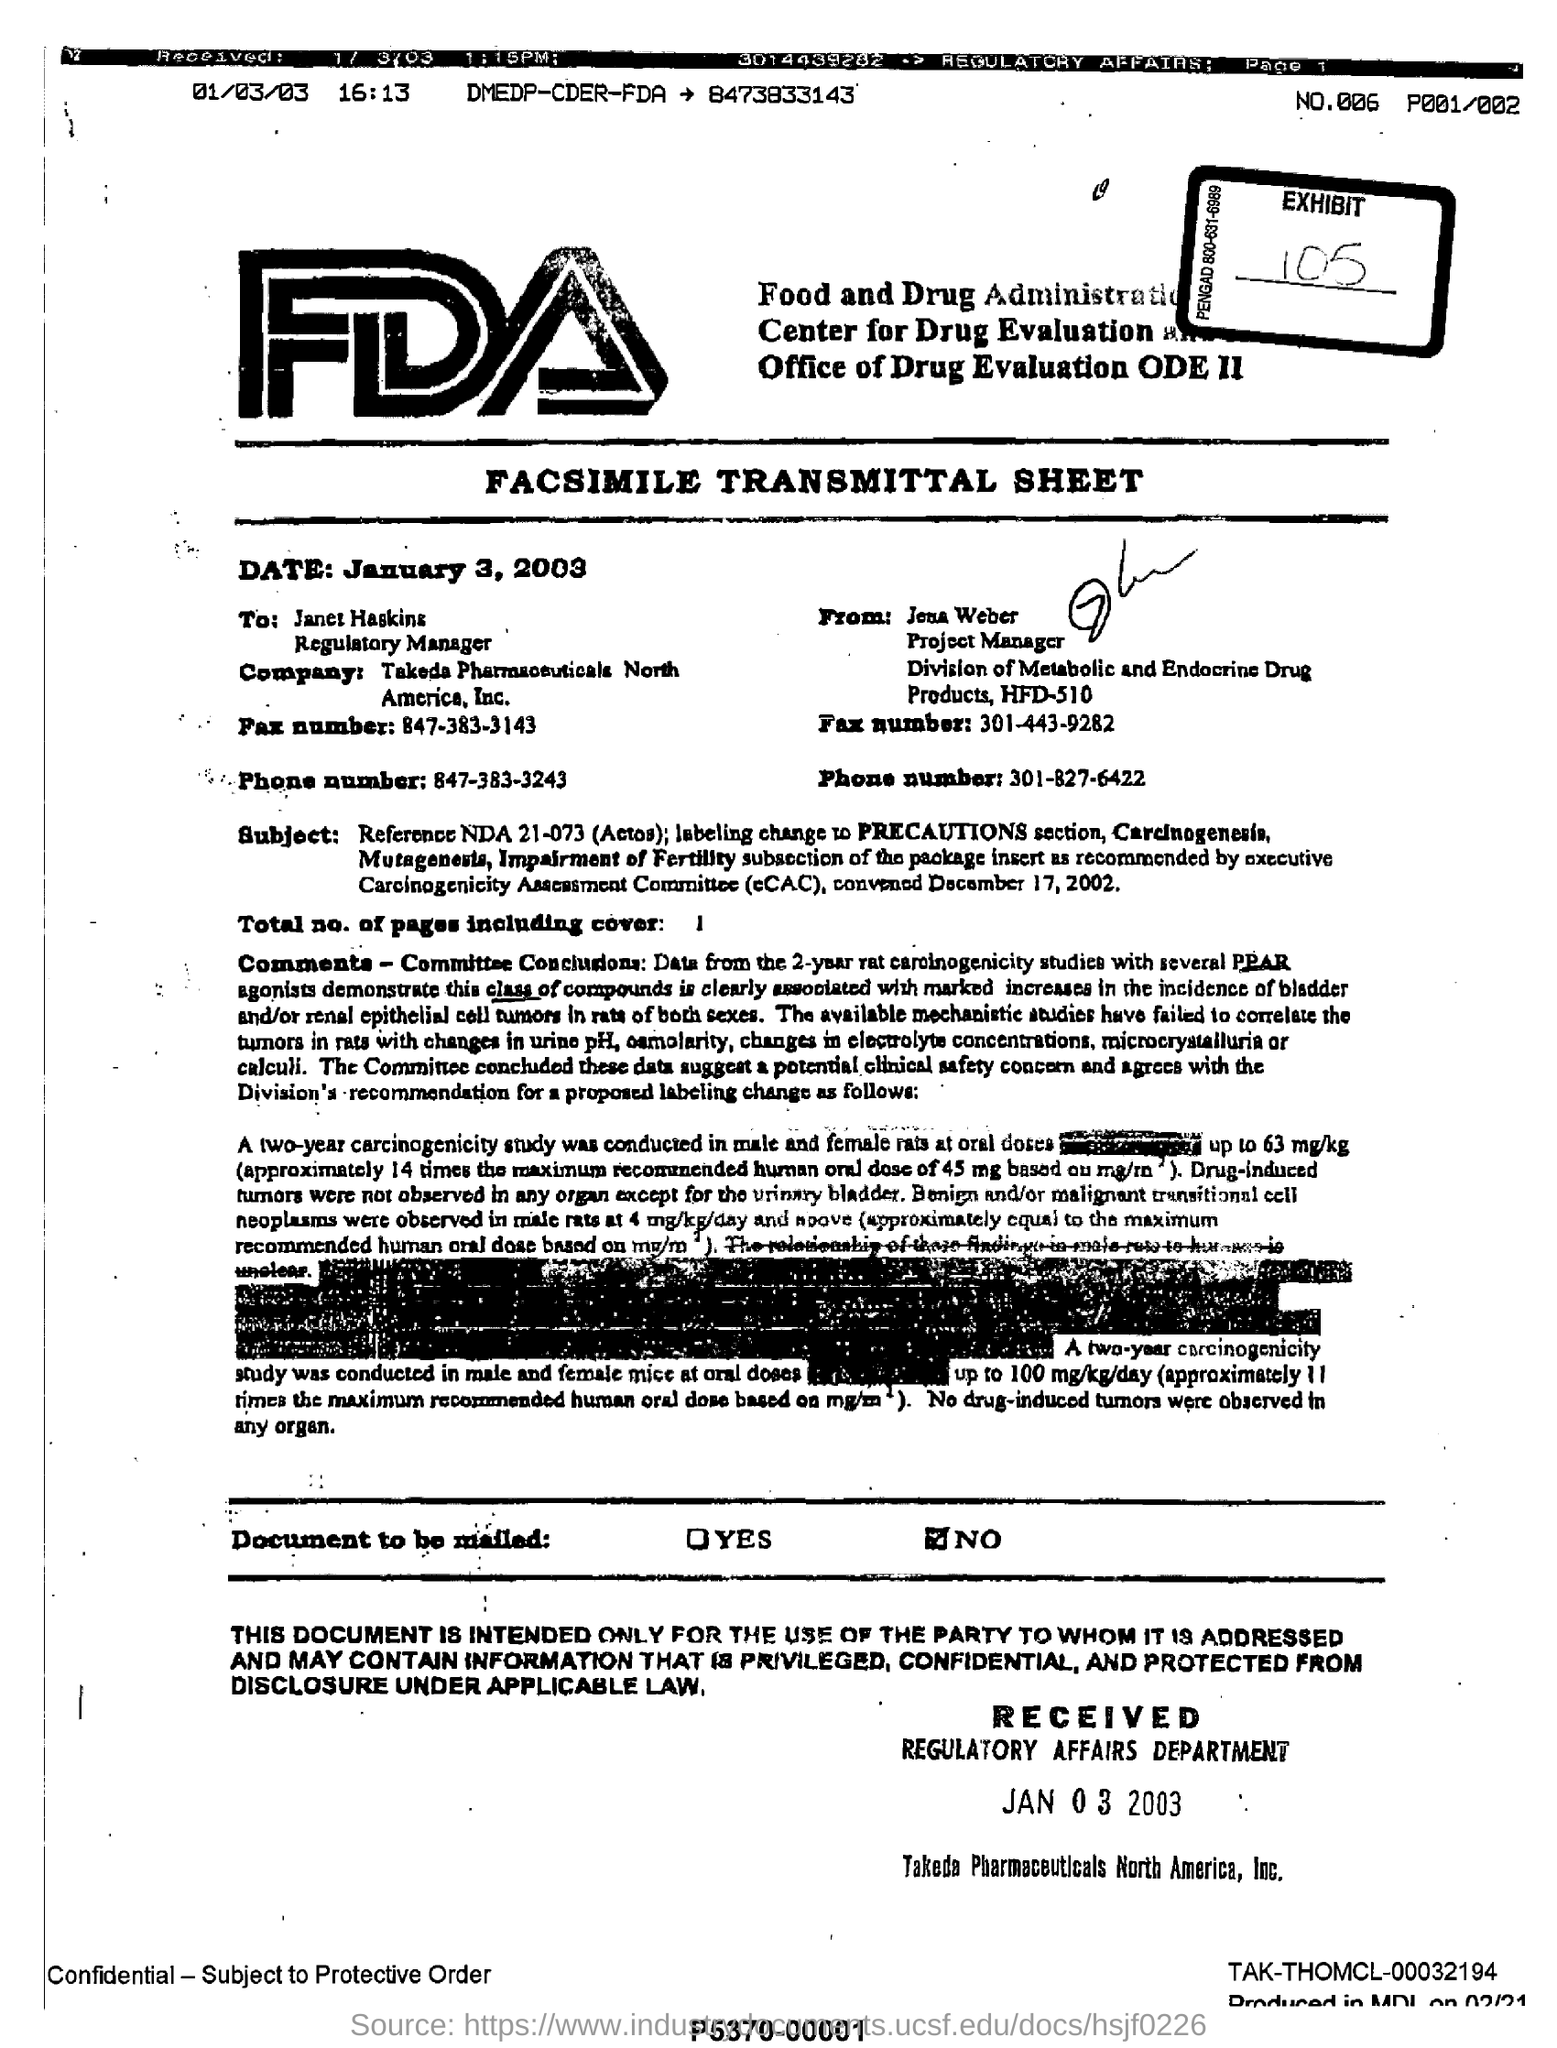Specify some key components in this picture. There are a total of one page, including the cover page, in the fax. The date mentioned is January 3, 2003. The fax sender is Jena Weber. The Food and Drug Administration, commonly referred to as FDA, is an agency responsible for regulating and overseeing the safety and efficacy of food and drugs in the United States. 